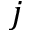<formula> <loc_0><loc_0><loc_500><loc_500>j</formula> 